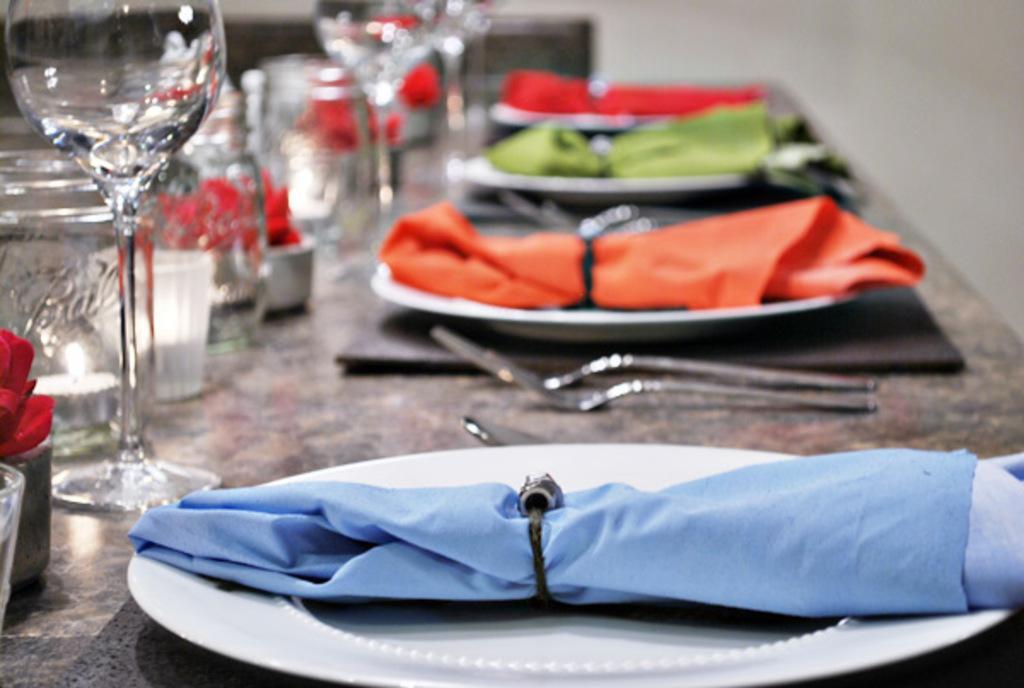Can you describe this image briefly? In this image, I can see glasses, fork, spoon, dining placemats, napkins in the plates, a candle in a jar and few other objects on a table. There is a blurred background. 